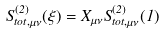Convert formula to latex. <formula><loc_0><loc_0><loc_500><loc_500>S _ { t o t , \mu \nu } ^ { ( 2 ) } ( \xi ) = X _ { \mu \nu } S _ { t o t , \mu \nu } ^ { ( 2 ) } ( 1 )</formula> 